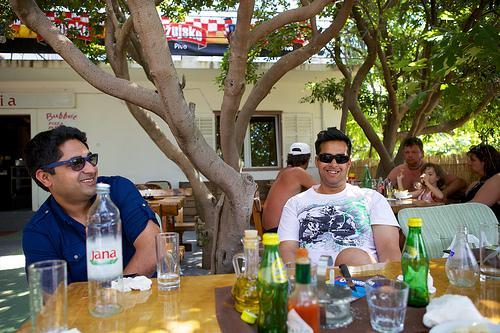Describe any interesting objects that stand out in the outdoor area of the image. Entryway into a restaurant, sign on the side of the building, brown wooden picket fence, a tree trunk between two men. Analyze the interaction between the man wearing a blue shirt and the man wearing a white shirt. The two men are sitting across from each other at a table, possibly having a conversation or sharing a meal. List any beverage bottles present in the image and their characteristics. Empty water bottle, two green bottles with yellow caps, clear plastic water bottle, clear glass bottle of olive oil, small bottle of oil, green clear bottle with a yellow cap, green glass bottle with yellow cap, tall bottle of water, bottle of Tabasco sauce. How many people are there in the image and what are they mostly doing? There are several people, mainly sitting around tables and talking. Provide a list of all objects related to tables and seating. People sitting around tables, glass sitting on the table, white napkin laying on the table, sun shining on the wooden table top, clear drinking glass on the table, clear plastic water bottle on the table, two men sitting at a table together, small bottle of oil on the table, a small empty tumbler on the table. Discuss the quality of the image based on the clarity of objects. The image is of decent quality, with the objects being well-defined and distinguishable. Provide a description of two particular men in the image, focusing on their eyewear. Two men wearing sunglasses - one in blue sunglasses, another in black. Count the number of glasses present in the image. There are four glasses - clear drinking glass on the table, tall empty drinking glass, a clear empty glass, and a small empty tumbler. What is the sentiment of the scene in the image? A casual and relaxed atmosphere. List objects with green and yellow cap in the image. two green bottles with yellow caps X:263 Y:216 Width:165 Height:165 Can you read any text on the sign on the side of the building? No Identify two distinctive colors of the shirts worn by the men in the image. Blue and white What are the colors of the two men's sunglasses? black and blue Is there any anomaly with the glass hot sauce bottle on the table? No. Does the man with the blue sunglasses have black hair? Yes. Count the number of people in the image. 10 Find the position of the brown wooden picket fence in the image. X:443 Y:148 Width:25 Height:25 What is the sentiment conveyed by the image? Neutral or positive, people are socializing and enjoying a meal. Is there a tree trunk with red flowers between the two men? This instruction is misleading because it suggests the presence of red flowers on the tree trunk, but the given information only mentions a tree trunk between two men without any details about the flowers. Can you see a man wearing yellow sunglasses in the image? This instruction is misleading because it wrongly attributes the color of sunglasses. The given information only mentions a man wearing blue sunglasses and another wearing black sunglasses, both without mentioning any yellow sunglasses. Can you spot a bottle of green colored hot sauce on the table? This instruction is misleading because it suggests the presence of a green colored hot sauce bottle, whereas the provided information only mentions a bottle of orange colored hot sauce on the table. Is there a purple drinking glass on the table? This instruction is misleading because it suggests the presence of a purple drinking glass, whereas the given information only mentions the clear drinking glass on the table. What is the most likely language of the sign in a foreign language in the image? Cannot determine without text. Can you find a shirtless man wearing a blue hat among the people? This instruction is misleading because it suggests that the shirtless man is wearing a blue hat, whereas the provided information states that he is wearing a white hat. Does the shirtless man wear a hat? Yes, white hat. What type of sauce can be found on the table? Orange colored hot sauce. Is the woman in the background wearing a red dress? The instruction is misleading because it wrongly attributes the color of the woman's dress, which isn't mentioned in the given information. Describe the interaction between the woman seated next to a child and the child. The child is drinking from a glass while seated next to the woman. Rate the image quality on a scale of 1 to 5, with 5 being the highest. 3 Describe the objects placed on the table. glasses, water bottles, hot sauce bottles, napkin, oil bottles Identify the referential expression for the man wearing a mostly white shirt. man wearing white shirt X:269 Y:129 Width:128 Height:128 What object is located between the two men in the image? tree trunk between two men X:55 Y:38 Width:260 Height:260 